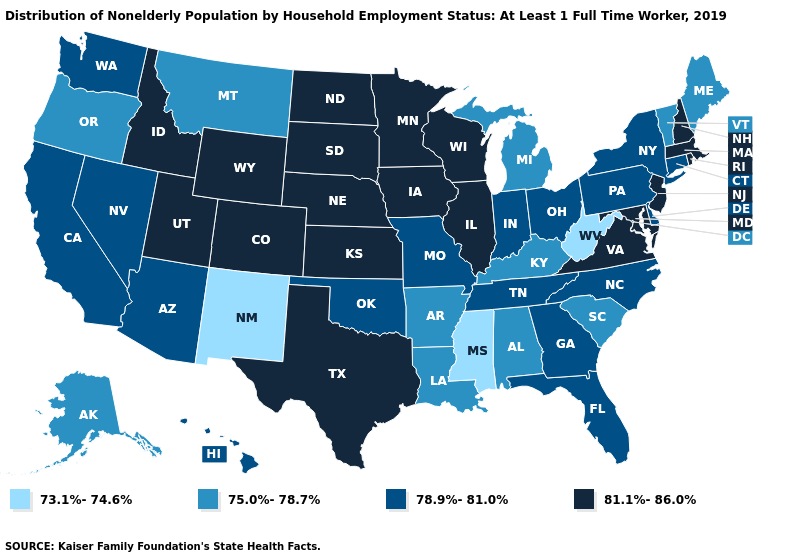What is the value of Texas?
Be succinct. 81.1%-86.0%. Does the map have missing data?
Give a very brief answer. No. Does Maine have the highest value in the Northeast?
Keep it brief. No. Name the states that have a value in the range 73.1%-74.6%?
Give a very brief answer. Mississippi, New Mexico, West Virginia. Which states have the highest value in the USA?
Keep it brief. Colorado, Idaho, Illinois, Iowa, Kansas, Maryland, Massachusetts, Minnesota, Nebraska, New Hampshire, New Jersey, North Dakota, Rhode Island, South Dakota, Texas, Utah, Virginia, Wisconsin, Wyoming. What is the value of Arizona?
Answer briefly. 78.9%-81.0%. Among the states that border California , does Nevada have the highest value?
Give a very brief answer. Yes. What is the lowest value in states that border Illinois?
Give a very brief answer. 75.0%-78.7%. Name the states that have a value in the range 75.0%-78.7%?
Short answer required. Alabama, Alaska, Arkansas, Kentucky, Louisiana, Maine, Michigan, Montana, Oregon, South Carolina, Vermont. Name the states that have a value in the range 81.1%-86.0%?
Concise answer only. Colorado, Idaho, Illinois, Iowa, Kansas, Maryland, Massachusetts, Minnesota, Nebraska, New Hampshire, New Jersey, North Dakota, Rhode Island, South Dakota, Texas, Utah, Virginia, Wisconsin, Wyoming. What is the value of Kentucky?
Give a very brief answer. 75.0%-78.7%. What is the value of New York?
Write a very short answer. 78.9%-81.0%. Name the states that have a value in the range 75.0%-78.7%?
Write a very short answer. Alabama, Alaska, Arkansas, Kentucky, Louisiana, Maine, Michigan, Montana, Oregon, South Carolina, Vermont. What is the highest value in the USA?
Give a very brief answer. 81.1%-86.0%. Does Arizona have the same value as South Carolina?
Keep it brief. No. 